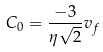Convert formula to latex. <formula><loc_0><loc_0><loc_500><loc_500>C _ { 0 } = \frac { - 3 } { \eta \sqrt { 2 } } v _ { f }</formula> 